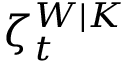Convert formula to latex. <formula><loc_0><loc_0><loc_500><loc_500>\zeta _ { t } ^ { W | K }</formula> 